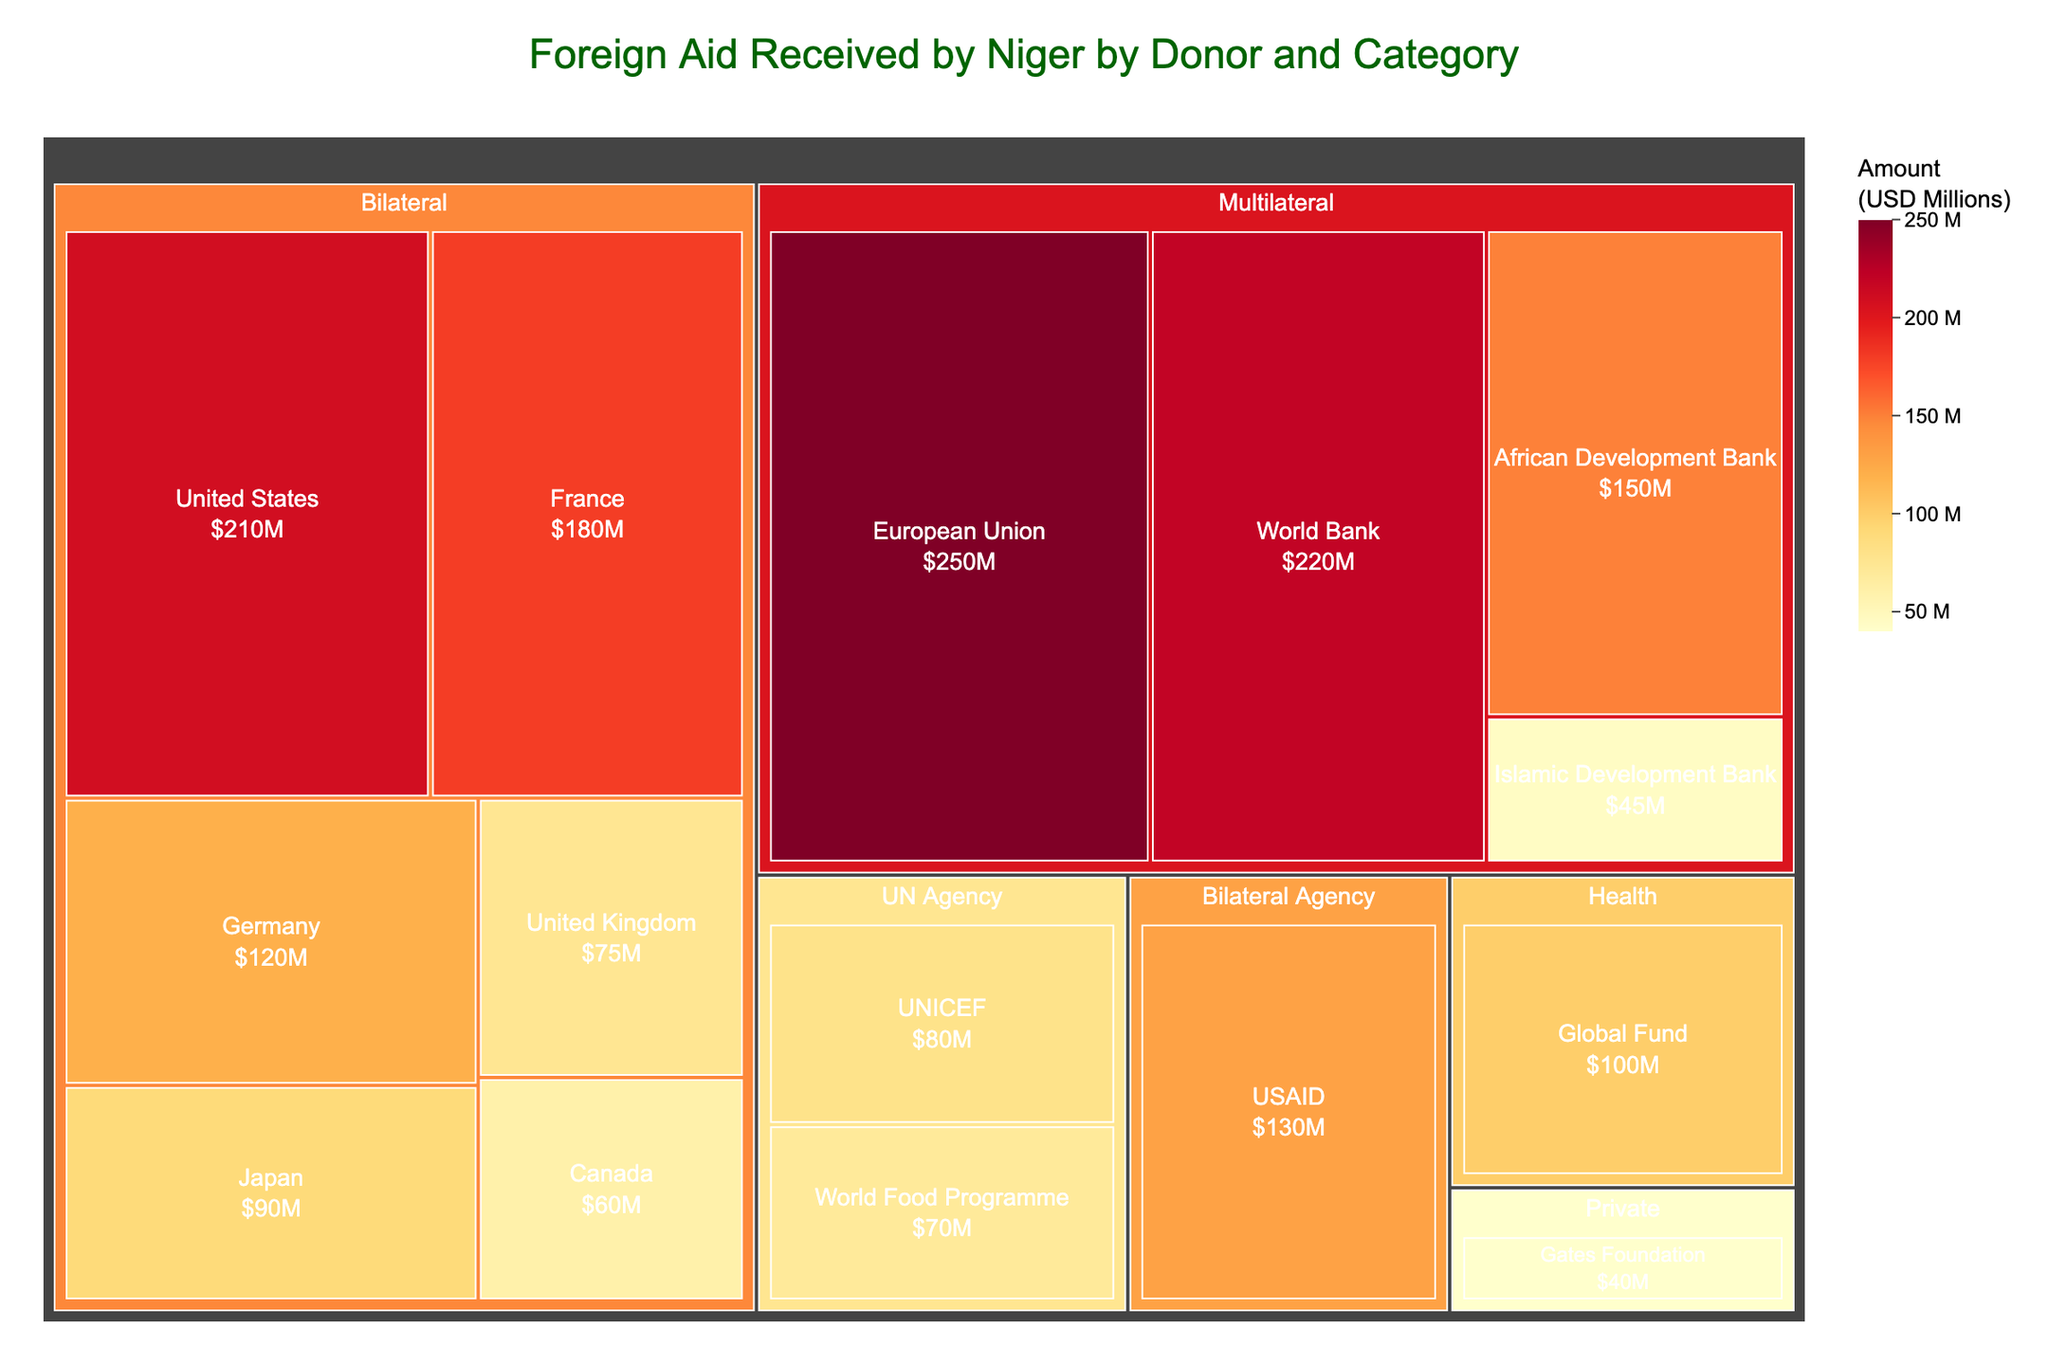What is the title of the treemap? The title of the treemap is usually at the top of the figure and provides an overview of what the visualization represents.
Answer: Foreign Aid Received by Niger by Donor and Category Which donor category has the highest total aid amount? By looking at the treemap tiles, compare the overall size (area) of the categories. The one with the largest combined area represents the highest total aid.
Answer: Multilateral What is the total aid amount contributed by Bilateral donors? Sum the values of the amounts contributed by all donors listed under the Bilateral category. The donors in this category are listed as United States, France, Germany, Japan, United Kingdom, Canada, and USAID. The sum is 210 + 180 + 120 + 90 + 75 + 60 + 130.
Answer: 865 million USD Which donor within the UN Agency category contributes more aid, UNICEF or World Food Programme? Compare the individual values of UNICEF and World Food Programme. UNICEF has an amount of 80 million USD, and World Food Programme has an amount of 70 million USD.
Answer: UNICEF What is the difference in aid amounts between the top two Multilateral donors? Identify the top two Multilateral donors (European Union and World Bank) and subtract the lower amount from the higher amount. The EU contributes 250 million USD, and the World Bank contributes 220 million USD. The difference is 250 - 220.
Answer: 30 million USD How much aid do the private and health categories contribute in total? Sum the amounts from the categories Private and Health. Gates Foundation (Private) provides 40 million USD, and Global Fund (Health) provides 100 million USD. The sum is 40 + 100.
Answer: 140 million USD Which Bilateral Agency contributes aid, and how much? Identify the donor listed under Bilateral Agency and note the amount. USAID falls under this category with an aid amount of 130 million USD.
Answer: USAID, 130 million USD How does the aid amount from the African Development Bank compare to the Islamic Development Bank? Compare the individual amounts from these two banks. African Development Bank contributes 150 million USD, while Islamic Development Bank contributes 45 million USD.
Answer: African Development Bank contributes more What is the total aid amount received from all donors listed? Sum the amounts from all donors: 210 + 180 + 120 + 250 + 220 + 150 + 80 + 70 + 100 + 90 + 75 + 60 + 45 + 130 + 40.
Answer: 1820 million USD 